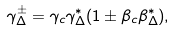Convert formula to latex. <formula><loc_0><loc_0><loc_500><loc_500>\gamma _ { \Delta } ^ { \pm } = \gamma _ { c } \gamma _ { \Delta } ^ { * } ( 1 \pm \beta _ { c } \beta _ { \Delta } ^ { * } ) ,</formula> 